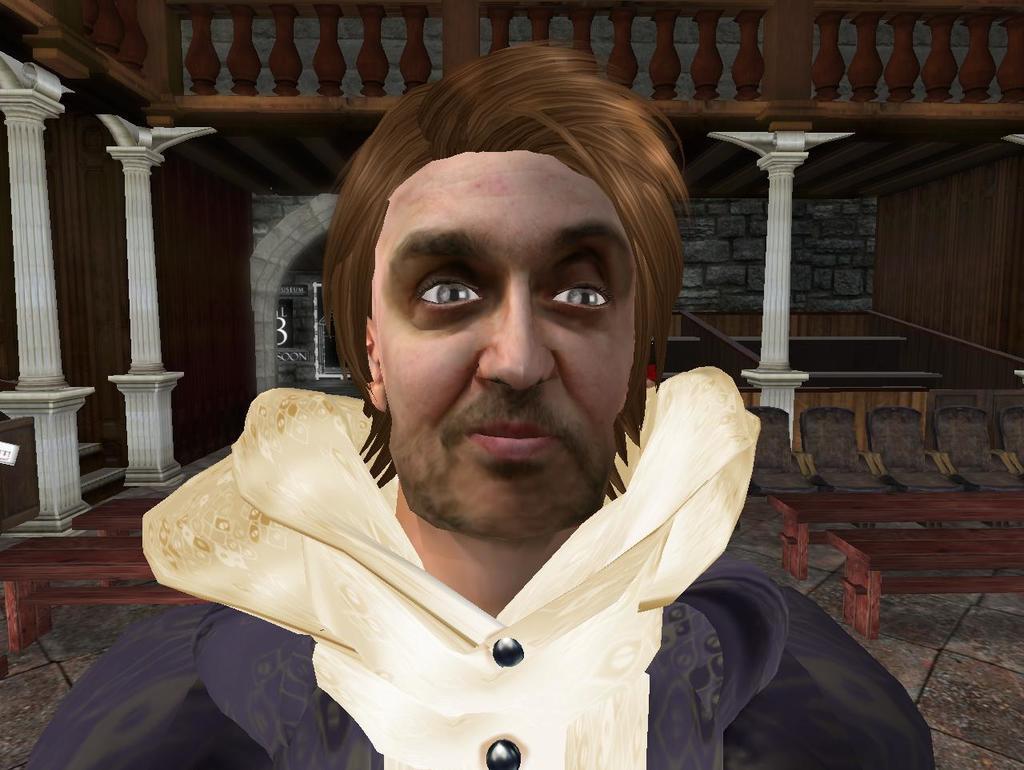Describe this image in one or two sentences. In this picture I can see there is a man standing and he is wearing a coat and there are chairs and tables in the backdrop. 